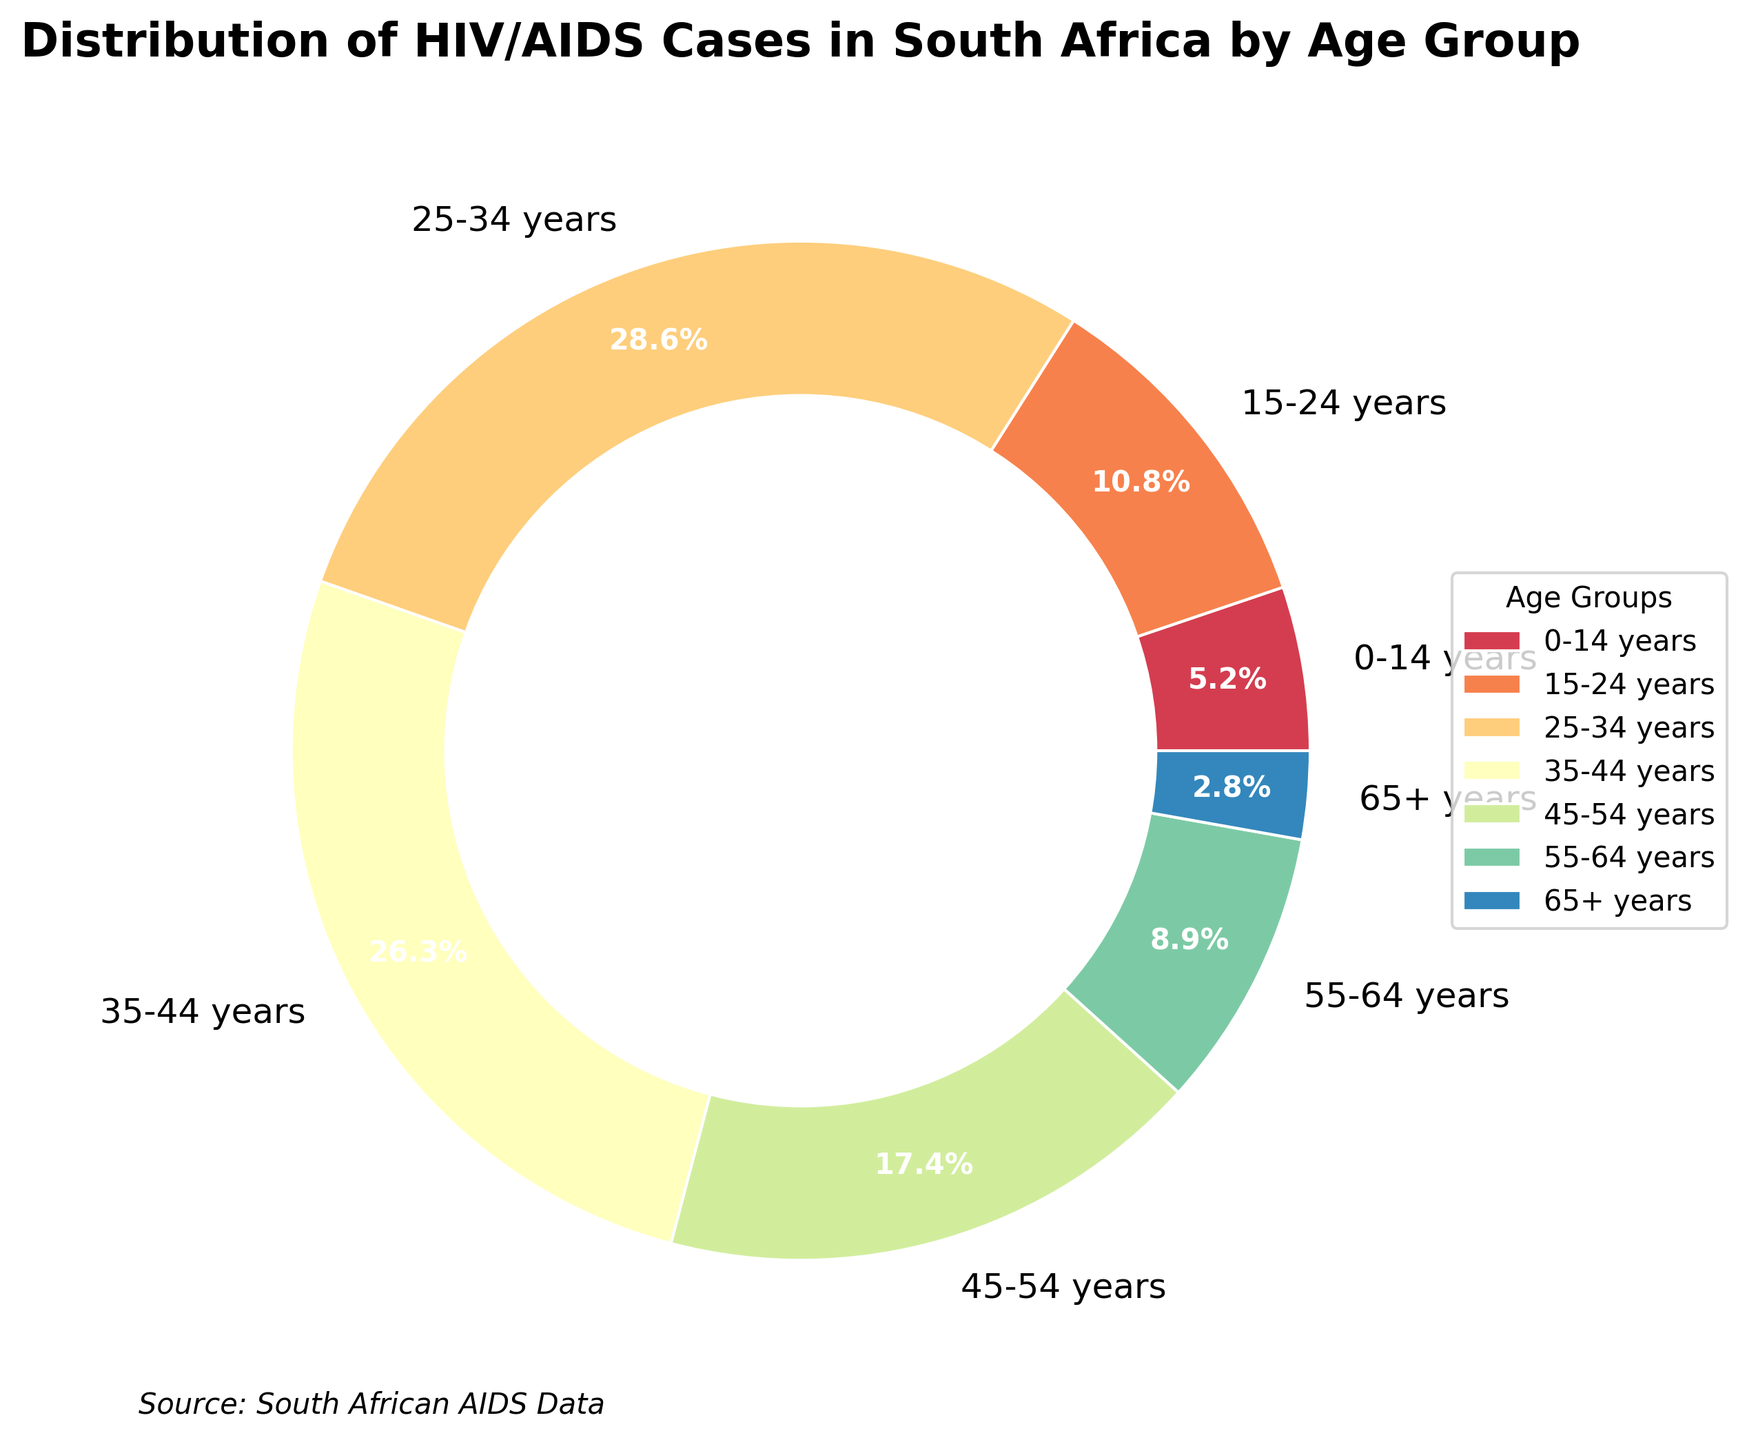What age group has the highest percentage of HIV/AIDS cases? The pie chart labels each age group with its percentage. The largest slice corresponds to the 25-34 years age group with 28.6%.
Answer: 25-34 years What age group has the smallest percentage of HIV/AIDS cases? The pie chart shows the smallest slice for the 65+ years age group, which is labeled with 2.8%.
Answer: 65+ years What is the sum of the percentages for the age groups under 25 years old? Add the percentages for the 0-14 years (5.2%) and 15-24 years (10.8%) age groups: 5.2% + 10.8% = 16.0%.
Answer: 16.0% Which age groups together account for more than half of the HIV/AIDS cases? Adding percentages from highest to lowest: 25-34 years (28.6%) + 35-44 years (26.3%) = 54.9%, which surpasses 50%. These two age groups together account for more than half.
Answer: 25-34 years, 35-44 years How much higher is the percentage of the 25-34 years age group compared to the 55-64 years age group? The 25-34 years age group has 28.6%, and the 55-64 years age group has 8.9%. Subtract 8.9% from 28.6%: 28.6% - 8.9% = 19.7%.
Answer: 19.7% Compare the percentage of the 35-44 years age group with that of the 45-54 years age group. Which one is higher, and by how much? The 35-44 years age group has 26.3%, while the 45-54 years age group has 17.4%. Subtract 17.4% from 26.3%: 26.3% - 17.4% = 8.9%. The 35-44 years group is higher.
Answer: 35-44 years, 8.9% What is the average percentage of HIV/AIDS cases for the age groups over 44 years old? Sum the percentages for the 45-54 years (17.4%), 55-64 years (8.9%), and 65+ years (2.8%) age groups and divide by 3: (17.4% + 8.9% + 2.8%) / 3 = 9.7%.
Answer: 9.7% Which age group has a percentage that is closest to 10%? The 15-24 years age group has a percentage of 10.8%, which is closest to 10%.
Answer: 15-24 years 